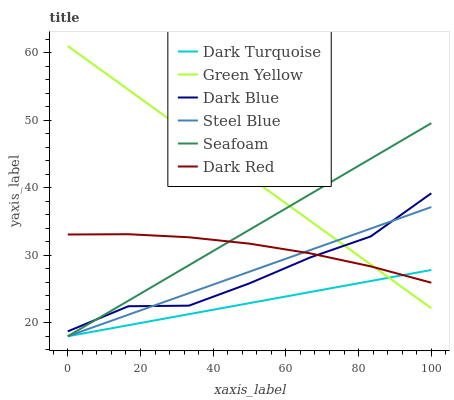Does Seafoam have the minimum area under the curve?
Answer yes or no. No. Does Seafoam have the maximum area under the curve?
Answer yes or no. No. Is Seafoam the smoothest?
Answer yes or no. No. Is Seafoam the roughest?
Answer yes or no. No. Does Dark Blue have the lowest value?
Answer yes or no. No. Does Seafoam have the highest value?
Answer yes or no. No. Is Dark Turquoise less than Dark Blue?
Answer yes or no. Yes. Is Dark Blue greater than Dark Turquoise?
Answer yes or no. Yes. Does Dark Turquoise intersect Dark Blue?
Answer yes or no. No. 